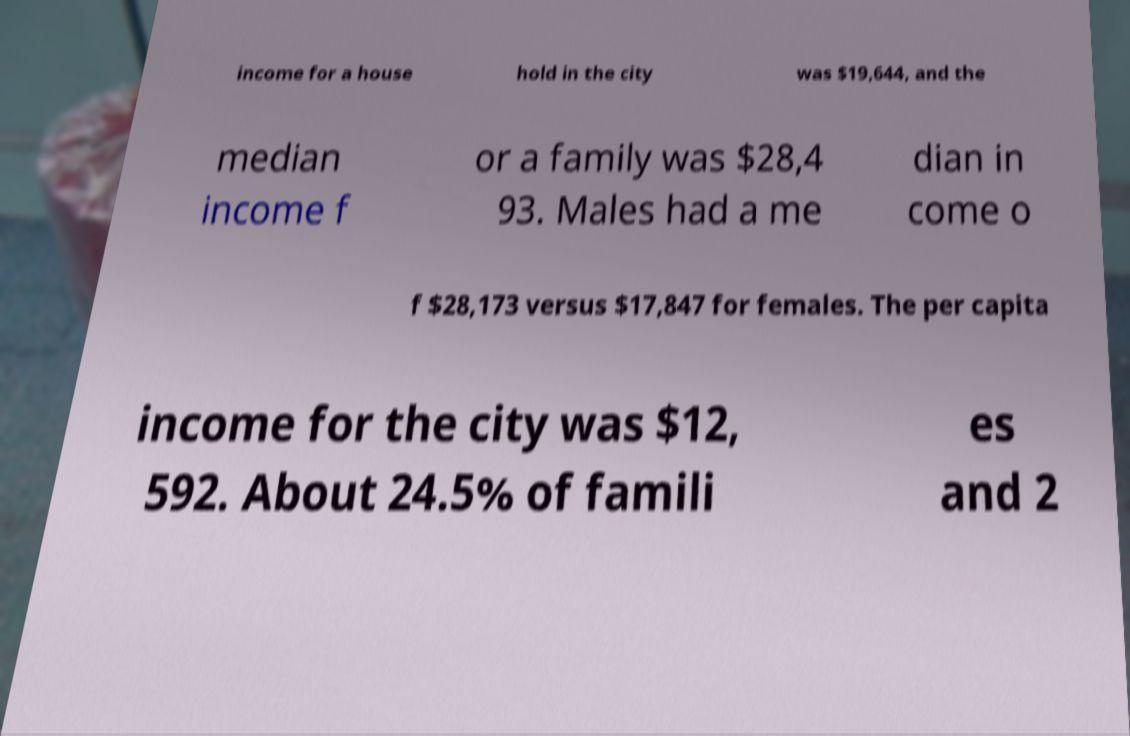What messages or text are displayed in this image? I need them in a readable, typed format. income for a house hold in the city was $19,644, and the median income f or a family was $28,4 93. Males had a me dian in come o f $28,173 versus $17,847 for females. The per capita income for the city was $12, 592. About 24.5% of famili es and 2 